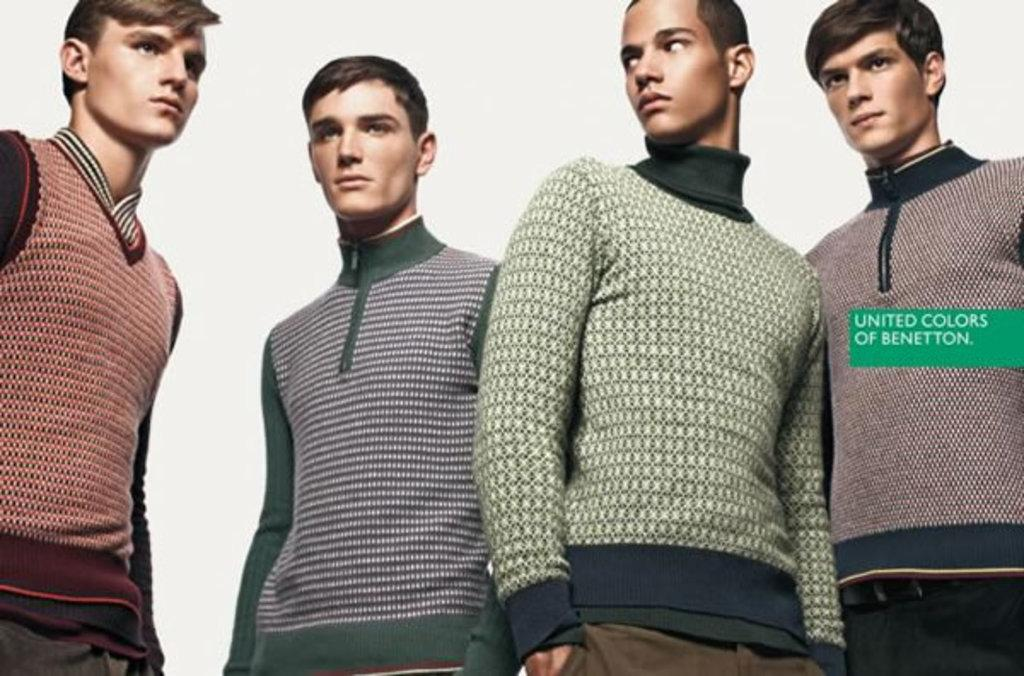How many people are in the image? There are four persons in the image. What are the persons wearing? The persons are wearing t-shirts. What are the persons doing in the image? The persons are standing. What is the color of the background in the image? The background in the image is white. Is there any additional visual element in the image? Yes, there is a green watermark in the image. What type of substance is being spilled in the image? There is no substance being spilled in the image. What kind of noise can be heard coming from the persons in the image? There is no noise present in the image, as it is a still photograph. 